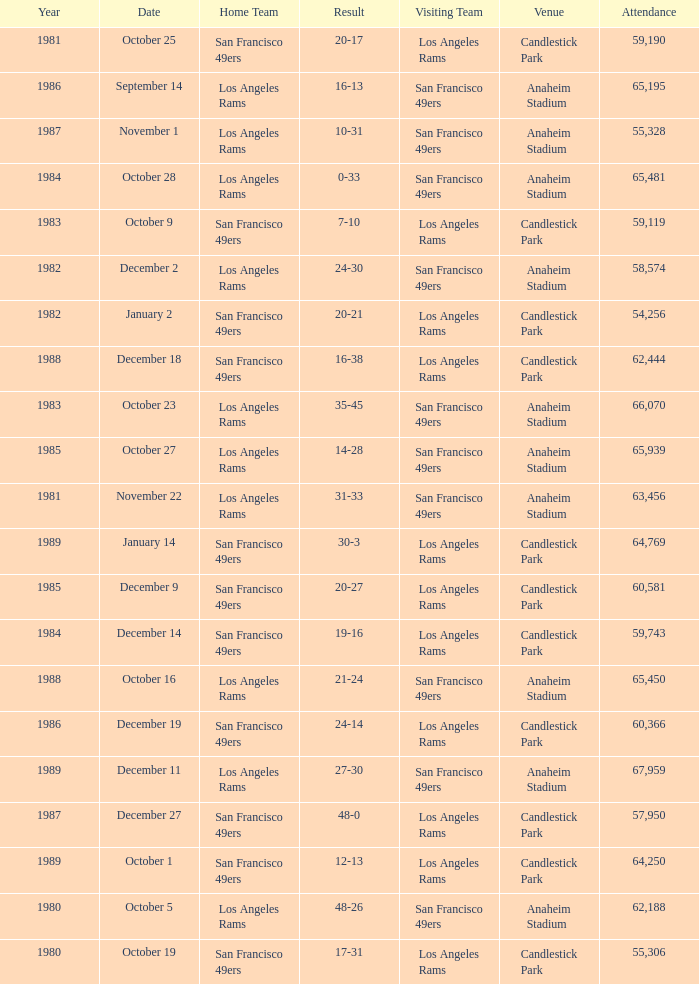What's the total attendance at anaheim stadium after 1983 when the result is 14-28? 1.0. 